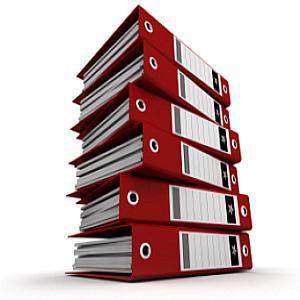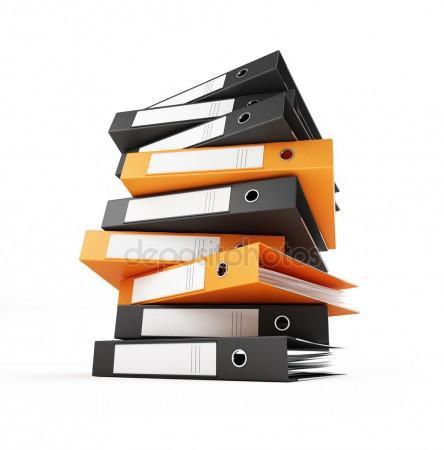The first image is the image on the left, the second image is the image on the right. Considering the images on both sides, is "There are stacks of binders with orange mixed with black" valid? Answer yes or no. Yes. The first image is the image on the left, the second image is the image on the right. For the images displayed, is the sentence "Multiple black and orange binders are stacked on top of one another" factually correct? Answer yes or no. Yes. 